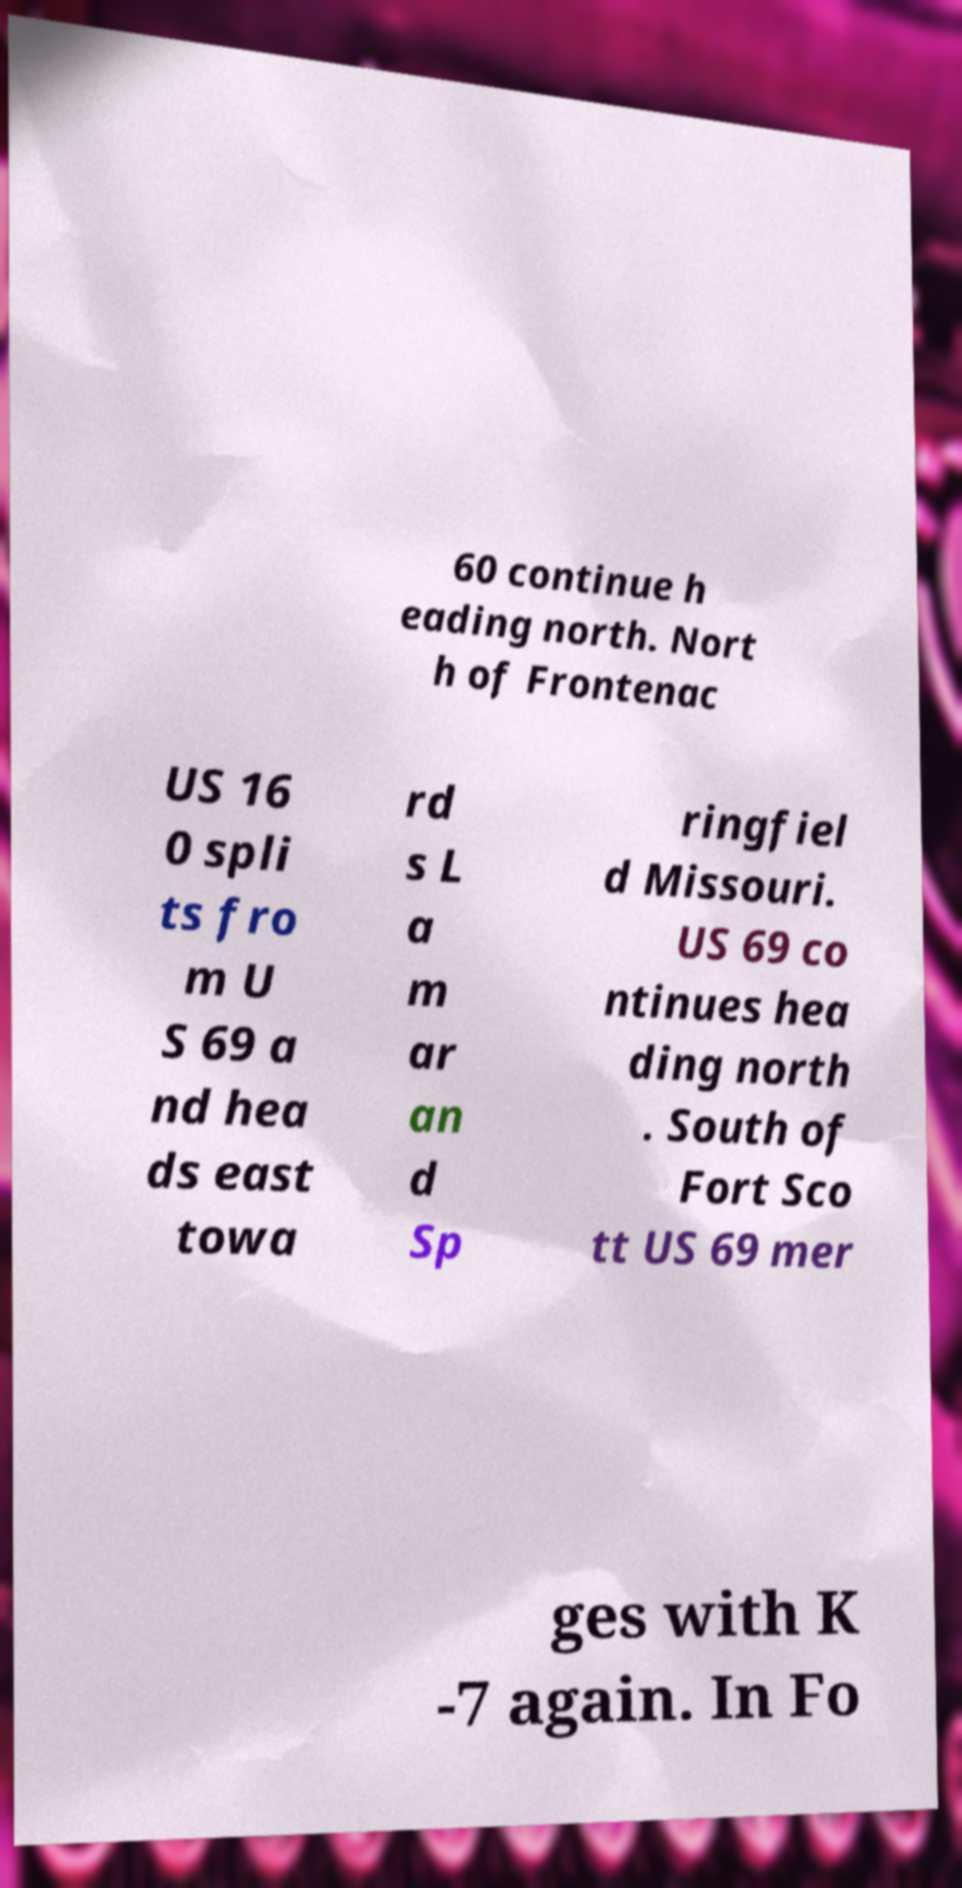Please identify and transcribe the text found in this image. 60 continue h eading north. Nort h of Frontenac US 16 0 spli ts fro m U S 69 a nd hea ds east towa rd s L a m ar an d Sp ringfiel d Missouri. US 69 co ntinues hea ding north . South of Fort Sco tt US 69 mer ges with K -7 again. In Fo 